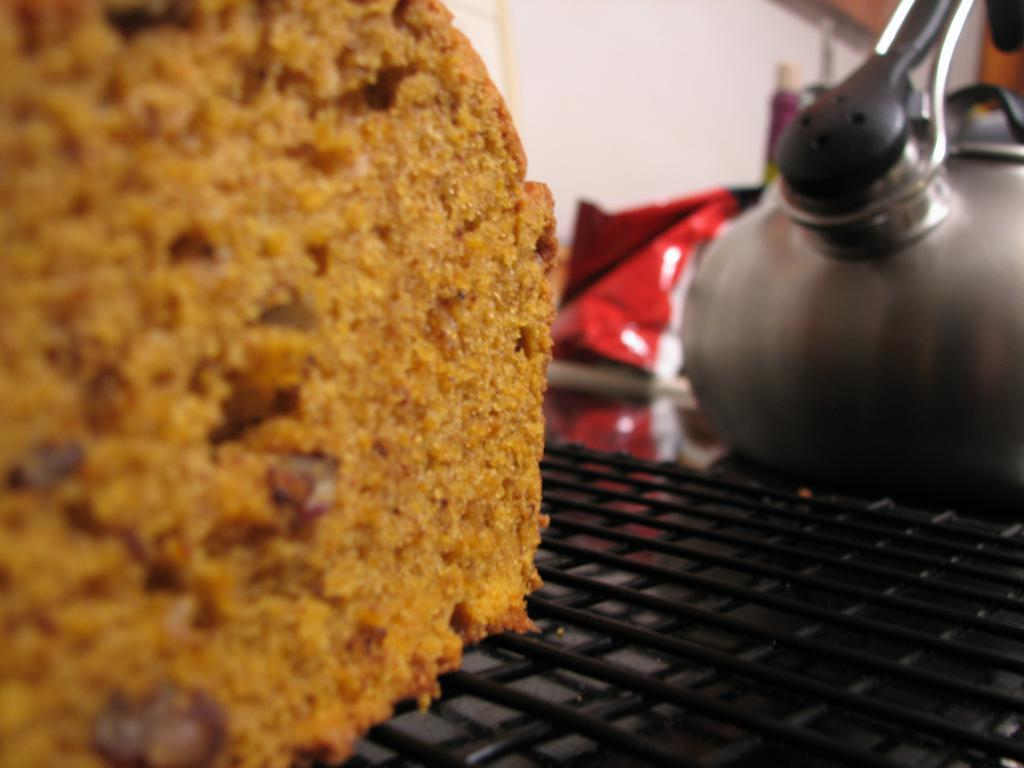What is the main subject of the image? The main subject of the image is a cake. Where is the cake located in the image? The cake is on a grill. What type of flowers can be seen growing around the cake in the image? There are no flowers present in the image; it only features a cake on a grill. Can you tell me how many giraffes are visible in the image? There are no giraffes present in the image; it only features a cake on a grill. 